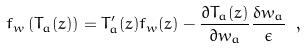<formula> <loc_0><loc_0><loc_500><loc_500>f _ { w } \left ( T _ { a } ( z ) \right ) = T _ { a } ^ { \prime } ( z ) f _ { w } ( z ) - \frac { \partial T _ { a } ( z ) } { \partial w _ { a } } \frac { \delta w _ { a } } { \epsilon } \ ,</formula> 